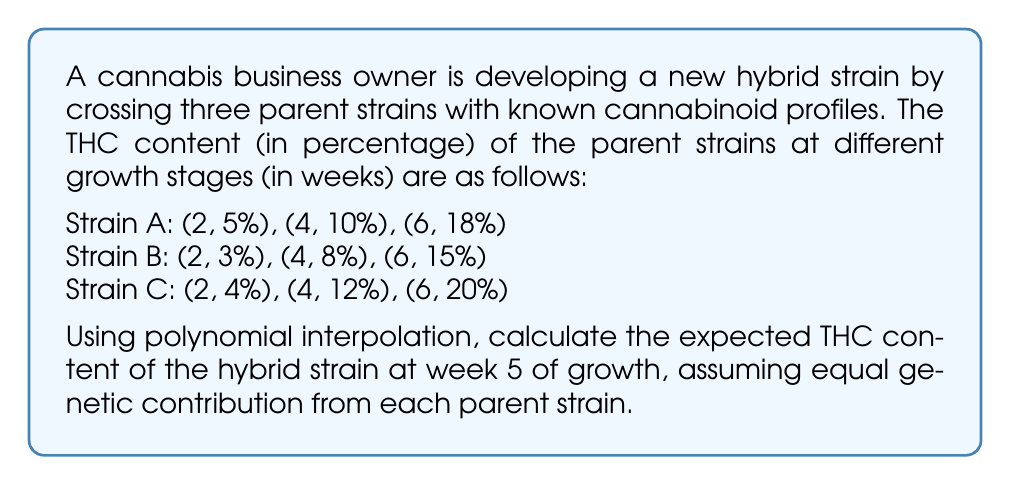Solve this math problem. To solve this problem, we'll use Lagrange polynomial interpolation for each strain and then take the average of the results. Here are the steps:

1. For each strain, we'll construct a second-degree polynomial of the form:
   $$P(x) = a_0 + a_1x + a_2x^2$$

2. Lagrange interpolation formula:
   $$P(x) = \sum_{i=0}^n y_i \prod_{j=0, j\neq i}^n \frac{x - x_j}{x_i - x_j}$$

3. For Strain A:
   $$P_A(x) = 5\cdot\frac{(x-4)(x-6)}{(2-4)(2-6)} + 10\cdot\frac{(x-2)(x-6)}{(4-2)(4-6)} + 18\cdot\frac{(x-2)(x-4)}{(6-2)(6-4)}$$
   $$P_A(x) = 5\cdot\frac{(x-4)(x-6)}{(-2)(-4)} + 10\cdot\frac{(x-2)(x-6)}{(2)(-2)} + 18\cdot\frac{(x-2)(x-4)}{(4)(2)}$$
   $$P_A(x) = \frac{5(x^2-10x+24)}{8} - \frac{10(x^2-8x+12)}{4} + \frac{18(x^2-6x+8)}{8}$$
   $$P_A(x) = \frac{5x^2-50x+120-20x^2+160x-240+18x^2-108x+144}{8}$$
   $$P_A(x) = \frac{3x^2+2x+24}{8} = \frac{3x^2}{8} + \frac{x}{4} + 3$$

4. Similarly, for Strain B:
   $$P_B(x) = \frac{3x^2}{8} + \frac{x}{4} + 1$$

5. And for Strain C:
   $$P_C(x) = \frac{3x^2}{4} - \frac{x}{2} + 2$$

6. The hybrid strain's THC content at week 5 will be the average of these three polynomials:
   $$P_H(x) = \frac{P_A(x) + P_B(x) + P_C(x)}{3}$$
   $$P_H(x) = \frac{(\frac{3x^2}{8} + \frac{x}{4} + 3) + (\frac{3x^2}{8} + \frac{x}{4} + 1) + (\frac{3x^2}{4} - \frac{x}{2} + 2)}{3}$$
   $$P_H(x) = \frac{\frac{9x^2}{8} + 0 + 6}{3} = \frac{3x^2}{8} + 2$$

7. Calculate the expected THC content at week 5:
   $$P_H(5) = \frac{3(5^2)}{8} + 2 = \frac{75}{8} + 2 = \frac{91}{8} = 11.375\%$$
Answer: 11.375% 